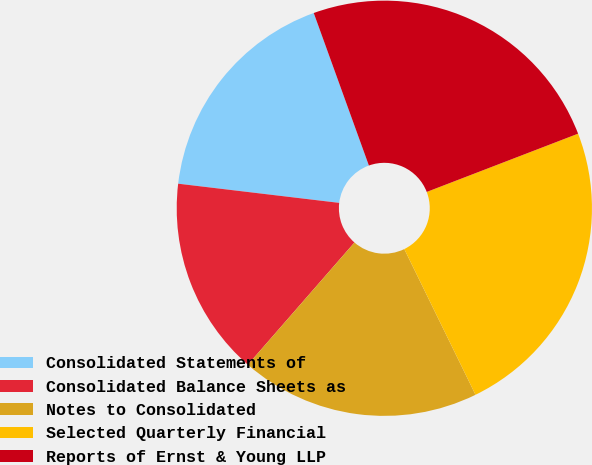<chart> <loc_0><loc_0><loc_500><loc_500><pie_chart><fcel>Consolidated Statements of<fcel>Consolidated Balance Sheets as<fcel>Notes to Consolidated<fcel>Selected Quarterly Financial<fcel>Reports of Ernst & Young LLP<nl><fcel>17.59%<fcel>15.47%<fcel>18.65%<fcel>23.61%<fcel>24.67%<nl></chart> 